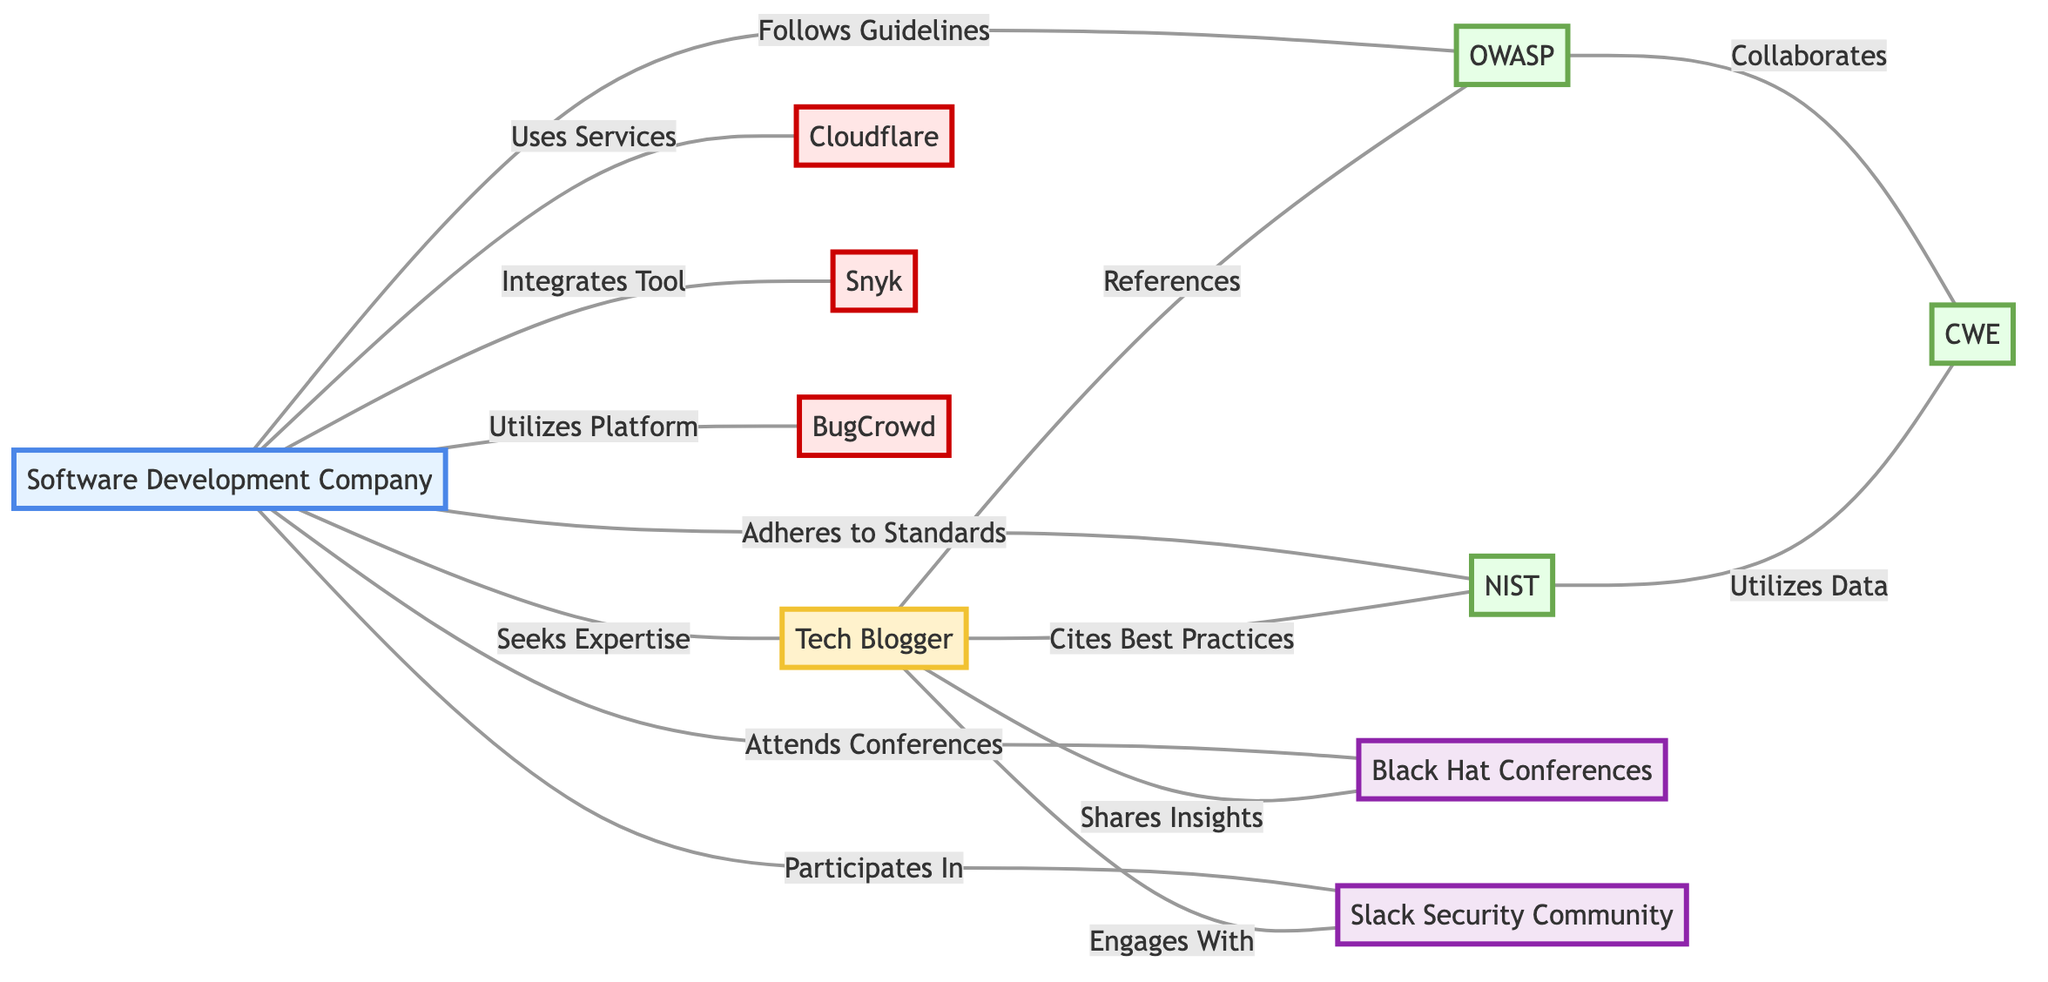What is the total number of nodes in the diagram? The diagram consists of eight distinct entities or nodes: Software Development Company, Tech Blogger, OWASP, NIST, Cloudflare, Black Hat Conferences, Snyk, CWE, BugCrowd, and Slack Security Community, resulting in a total of ten nodes.
Answer: 10 Which entity does the Software Development Company seek expertise from? The Software Development Company seeks expertise from the Tech Blogger, indicated by the edge labeled "Seeks Expertise" connecting the two.
Answer: Tech Blogger How many tools does the Software Development Company integrate or utilize? The Software Development Company integrates Snyk and utilizes BugCrowd, amounting to two tool-related connections in the diagram.
Answer: 2 What guidelines does the Software Development Company follow? The Software Development Company follows the guidelines provided by OWASP, as represented by the edge labeled "Follows Guidelines."
Answer: OWASP Which two organizations collaborate according to the diagram? OWASP collaborates with CWE, indicated by the edge labeled "Collaborates," while NIST utilizes data from CWE, suggesting a partnership among those three entities.
Answer: OWASP and CWE Which communities does the Software Development Company participate in? The Software Development Company participates in the Slack Security Community, as shown by the connection labeled "Participates In."
Answer: Slack Security Community Who cites best practices from NIST? The Tech Blogger cites best practices from NIST, as indicated by the edge labeled "Cites Best Practices" in the diagram.
Answer: Tech Blogger How many edges are connected to the Software Development Company? The Software Development Company is connected to seven edges, indicating its relationships with the Tech Blogger, OWASP, NIST, Cloudflare, Snyk, BugCrowd, and Black Hat Conferences.
Answer: 7 Which organization utilizes data from CWE? NIST utilizes data from CWE, as represented by the edge connecting these two entities, labeled "Utilizes Data."
Answer: NIST 